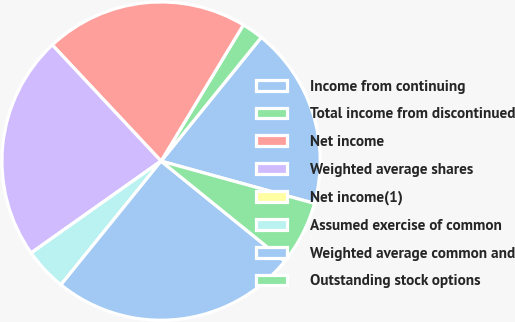<chart> <loc_0><loc_0><loc_500><loc_500><pie_chart><fcel>Income from continuing<fcel>Total income from discontinued<fcel>Net income<fcel>Weighted average shares<fcel>Net income(1)<fcel>Assumed exercise of common<fcel>Weighted average common and<fcel>Outstanding stock options<nl><fcel>18.45%<fcel>2.18%<fcel>20.63%<fcel>22.82%<fcel>0.0%<fcel>4.37%<fcel>25.0%<fcel>6.55%<nl></chart> 